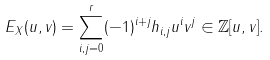Convert formula to latex. <formula><loc_0><loc_0><loc_500><loc_500>E _ { X } ( u , v ) = \sum _ { i , j = 0 } ^ { r } ( - 1 ) ^ { i + j } h _ { i , j } u ^ { i } v ^ { j } \in \mathbb { Z } [ u , v ] .</formula> 